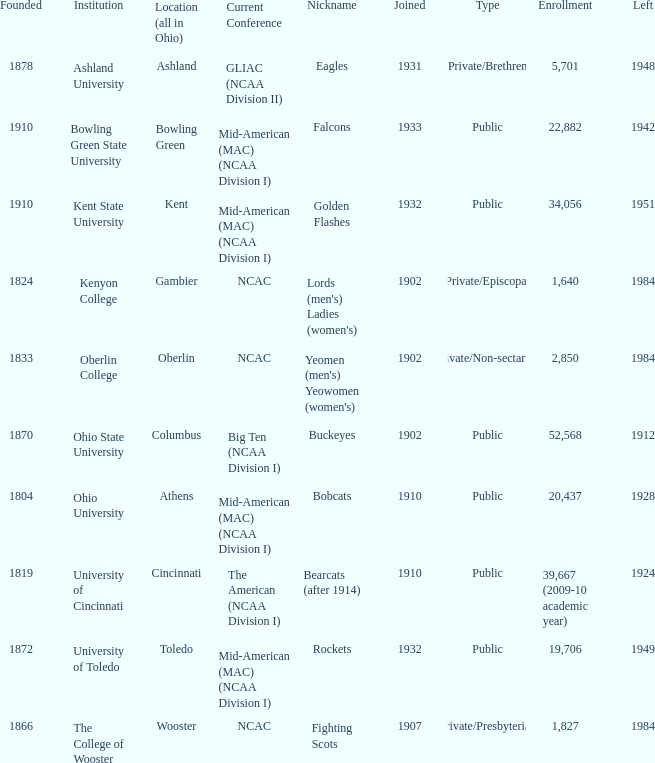What is the type of institution in Kent State University? Public. 